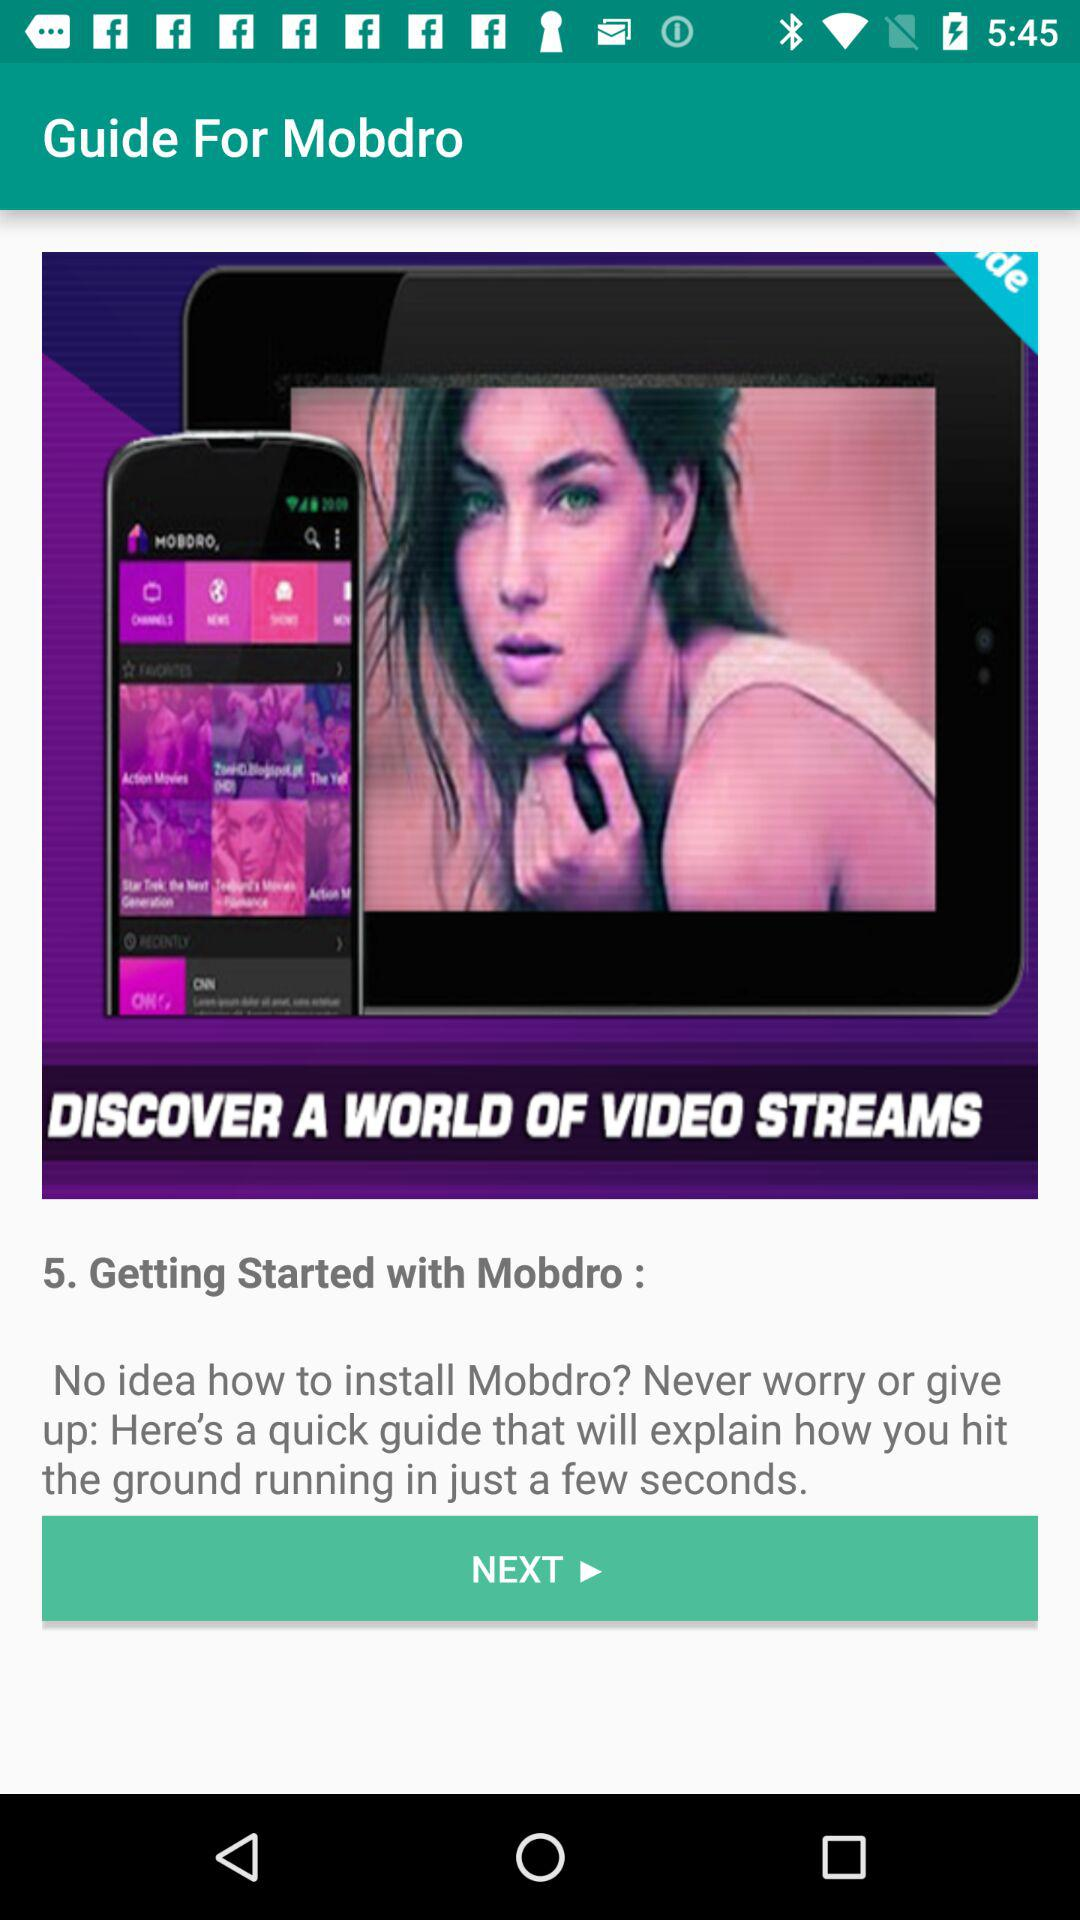How many steps are there in the guide?
Answer the question using a single word or phrase. 5 